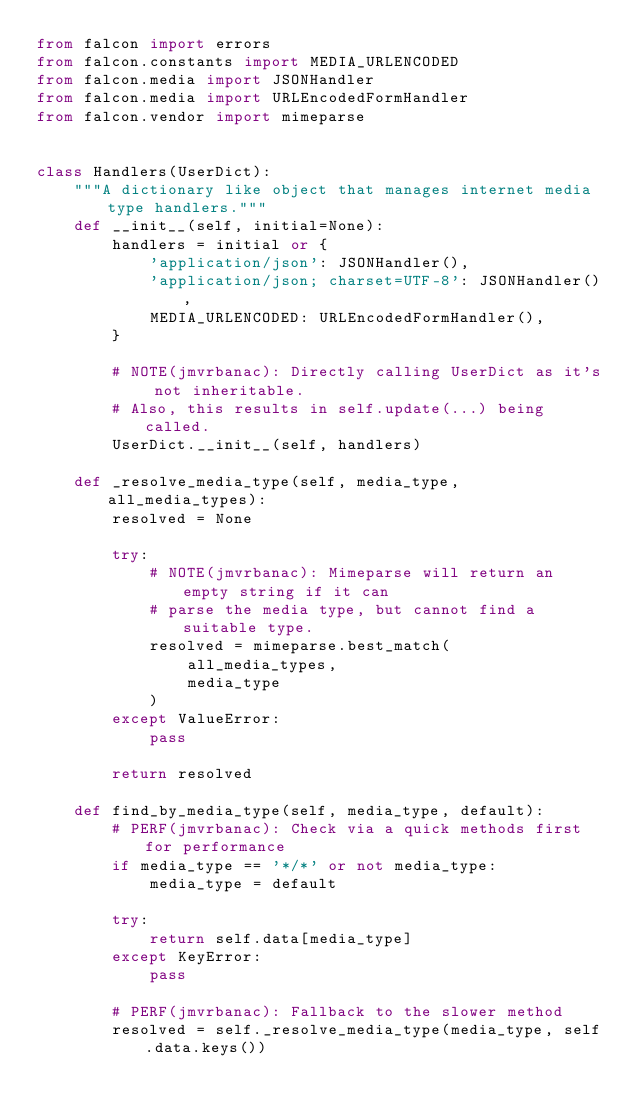Convert code to text. <code><loc_0><loc_0><loc_500><loc_500><_Python_>from falcon import errors
from falcon.constants import MEDIA_URLENCODED
from falcon.media import JSONHandler
from falcon.media import URLEncodedFormHandler
from falcon.vendor import mimeparse


class Handlers(UserDict):
    """A dictionary like object that manages internet media type handlers."""
    def __init__(self, initial=None):
        handlers = initial or {
            'application/json': JSONHandler(),
            'application/json; charset=UTF-8': JSONHandler(),
            MEDIA_URLENCODED: URLEncodedFormHandler(),
        }

        # NOTE(jmvrbanac): Directly calling UserDict as it's not inheritable.
        # Also, this results in self.update(...) being called.
        UserDict.__init__(self, handlers)

    def _resolve_media_type(self, media_type, all_media_types):
        resolved = None

        try:
            # NOTE(jmvrbanac): Mimeparse will return an empty string if it can
            # parse the media type, but cannot find a suitable type.
            resolved = mimeparse.best_match(
                all_media_types,
                media_type
            )
        except ValueError:
            pass

        return resolved

    def find_by_media_type(self, media_type, default):
        # PERF(jmvrbanac): Check via a quick methods first for performance
        if media_type == '*/*' or not media_type:
            media_type = default

        try:
            return self.data[media_type]
        except KeyError:
            pass

        # PERF(jmvrbanac): Fallback to the slower method
        resolved = self._resolve_media_type(media_type, self.data.keys())
</code> 